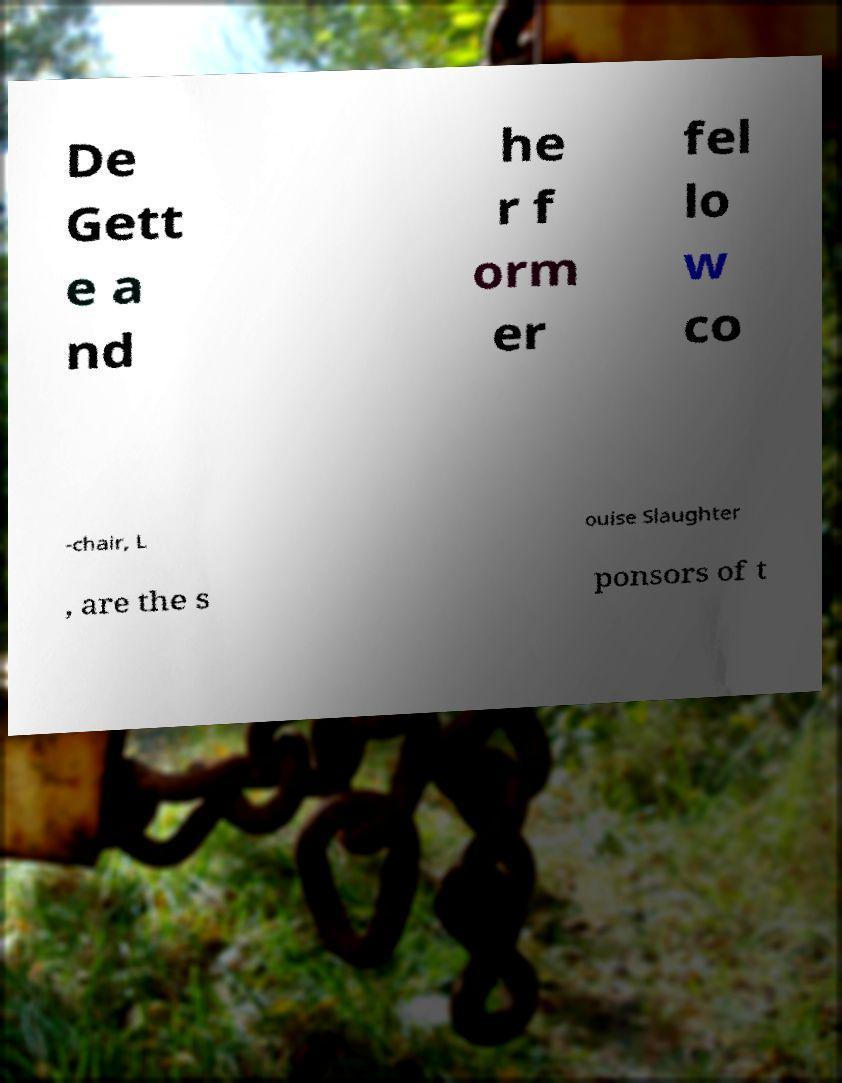For documentation purposes, I need the text within this image transcribed. Could you provide that? De Gett e a nd he r f orm er fel lo w co -chair, L ouise Slaughter , are the s ponsors of t 